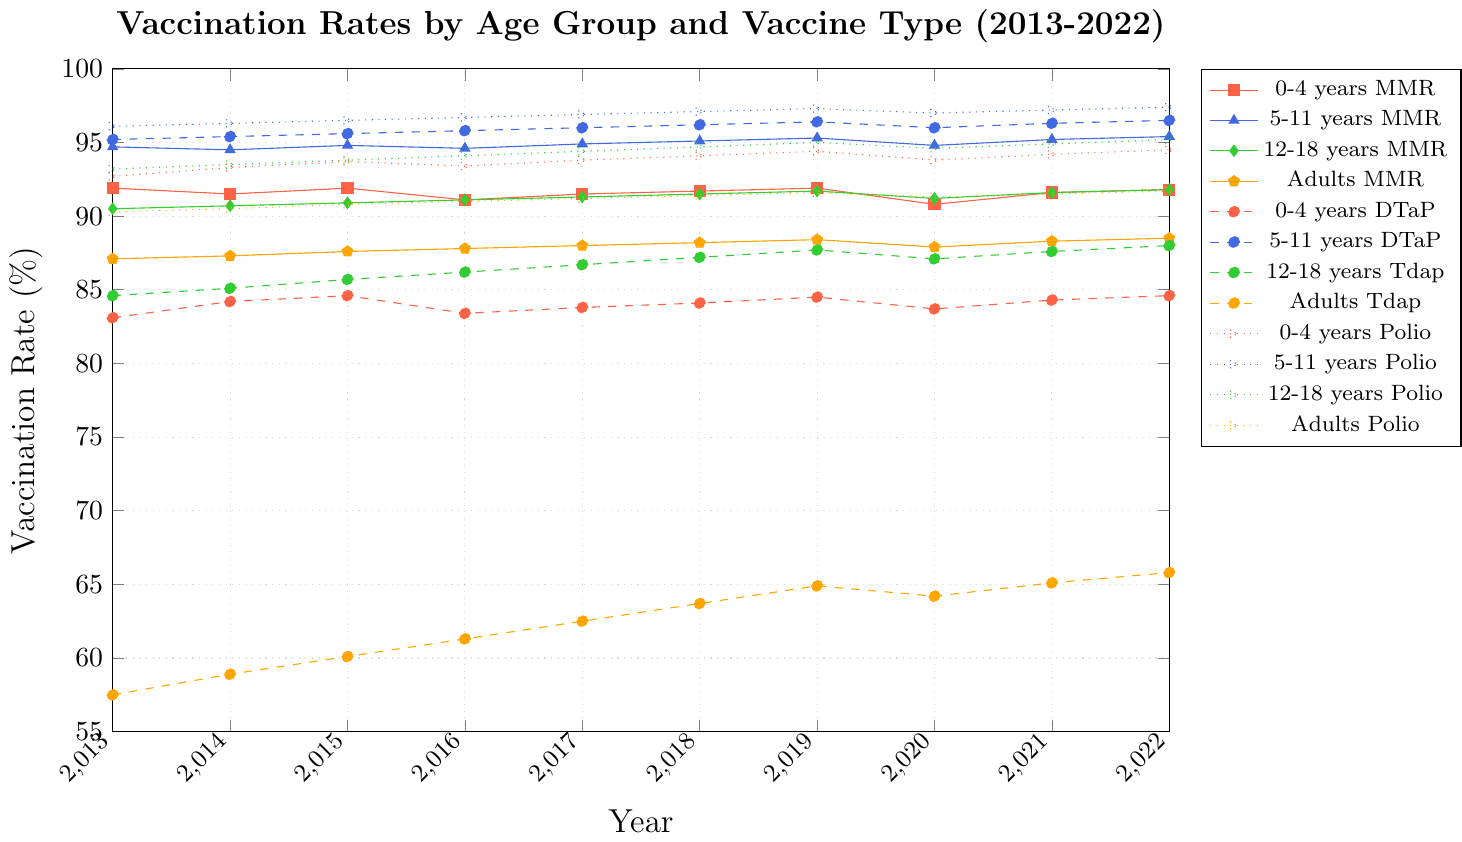Which age group had the highest vaccination rate for MMR in 2022? Look at the MMR vaccination rates for all age groups in 2022. The highest value is among the 5-11 years age group with a rate of 95.4%.
Answer: 5-11 years What was the trend in Adults Tdap vaccination rates from 2013 to 2022? Observe the line representing Adults Tdap vaccination rates from 2013 to 2022. The rate increased from 57.5% in 2013 to 65.8% in 2022 despite small fluctuations.
Answer: Increasing How does the 2020 MMR vaccination rate for 12-18 years compare to the 2021 rate for the same group? Compare the MMR vaccination rate for the 12-18 years group in 2020 which is 91.2% with the 2021 rate which is 91.6%. The rate increased by 0.4%.
Answer: Increased by 0.4% What is the range of the 5-11 years Polio vaccination rates over the entire period? The range is the difference between the maximum and minimum values. The maximum rate for 5-11 years Polio is 97.4% in 2022 and the minimum is 96.1% in 2013, so the range is 97.4% - 96.1% = 1.3%.
Answer: 1.3% Which vaccine showed the largest increase in vaccination rates for adults from 2013 to 2022? Compare the increase in vaccination rates for all adult vaccines from 2013 to 2022. DTaP increased from 57.5% to 65.8%, equating to an 8.3% increase, which is the largest.
Answer: Tdap Between which consecutive years did the 5-11 years DTaP vaccination rates experience the largest increase? Calculate the annual differences in 5-11 years DTaP rates. The largest increase occurred between 2014 (95.4%) and 2015 (95.6%), an increase of 0.2%.
Answer: 2014-2015 What is the average vaccination rate for 0-4 years Polio from 2013 to 2022? Sum the 0-4 years Polio vaccination rates from 2013 to 2022 and divide by the total number of years (10). The rates are 92.7, 93.3, 93.7, 93.4, 93.8, 94.1, 94.4, 93.8, 94.2, and 94.5. The sum is 937.9, so the average is 937.9/10 = 93.79%.
Answer: 93.79% Which age group has the lowest rate of Polio vaccination in 2020? Compare the Polio vaccination rates across all age groups in 2020. The lowest rate is for 0-4 years Polio vaccination at 93.8%.
Answer: 0-4 years How did the vaccination rate for 12-18 years Tdap change between 2018 and 2022? Look at the 12-18 years Tdap rates in 2018 (87.2%) and 2022 (88.0%). The increase is 88.0% - 87.2% = 0.8%.
Answer: Increased by 0.8% Which age group shows the most consistent trend in vaccination rates for a single vaccine type from 2013 to 2022? Evaluate all vaccination trends for consistency. The 5-11 years Polio vaccination rates are very stable, ranging only from 96.1% to 97.4%, showing the most consistent trend.
Answer: 5-11 years Polio 